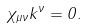Convert formula to latex. <formula><loc_0><loc_0><loc_500><loc_500>\chi _ { \mu \nu } k ^ { \nu } = 0 .</formula> 